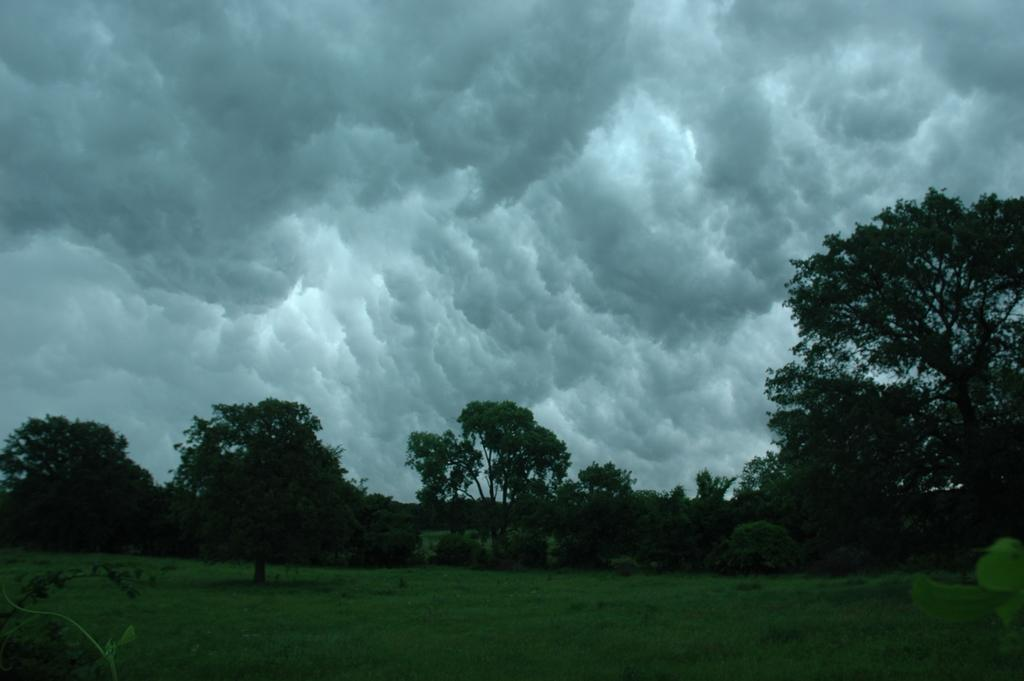What type of vegetation can be seen in the image? There is a group of trees, plants, and grass in the image. What part of the natural environment is visible in the image? The grass and the sky are visible in the image. What is the condition of the sky in the image? The sky appears to be cloudy in the image. Where can the store selling honey be found in the image? There is no store or honey present in the image; it features a group of trees, plants, grass, and a cloudy sky. What is the hope of the plants in the image? The image does not convey any emotions or intentions of the plants, so it is not possible to determine their hope. 